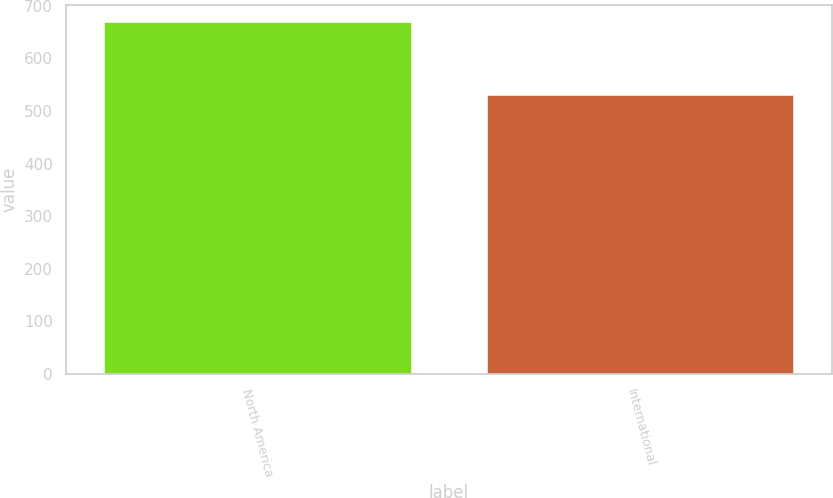Convert chart to OTSL. <chart><loc_0><loc_0><loc_500><loc_500><bar_chart><fcel>North America<fcel>International<nl><fcel>668.3<fcel>531.1<nl></chart> 